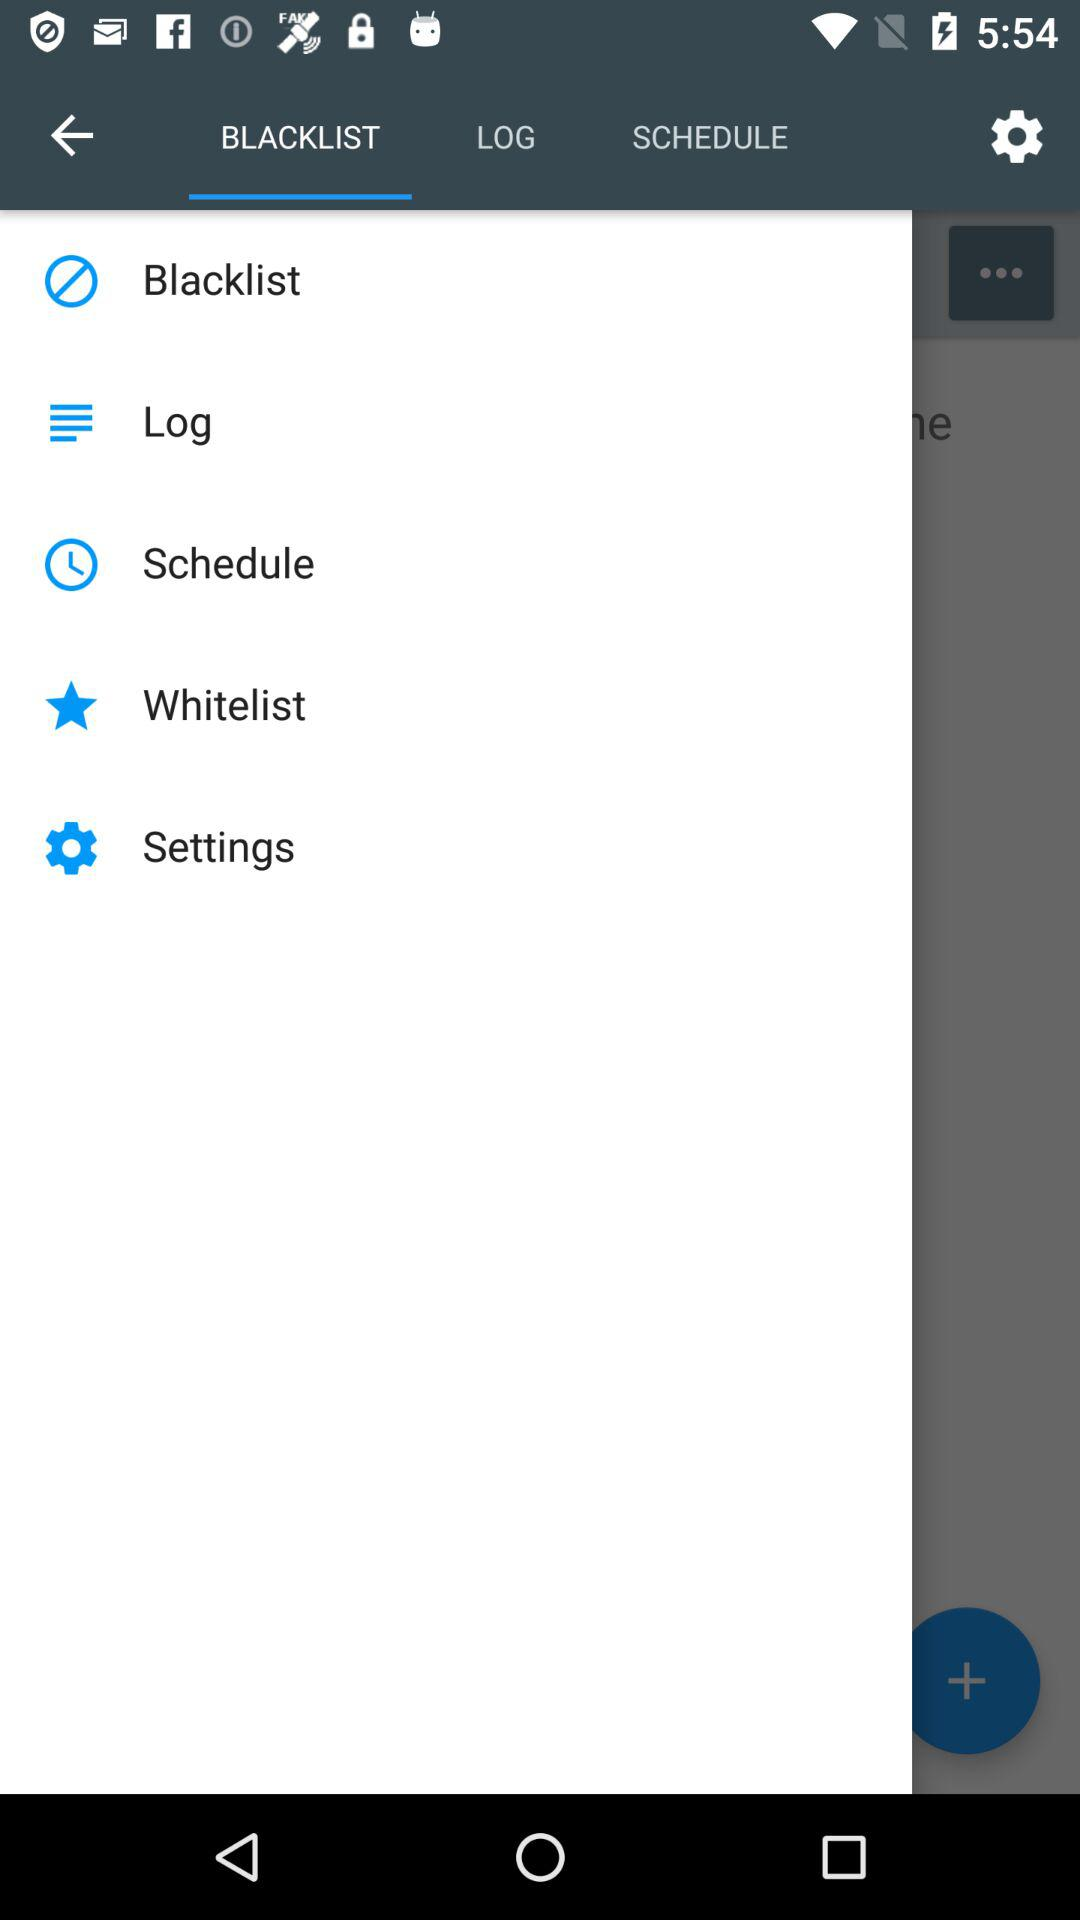Which tab is selected? The selected tab is "BLACKLIST". 